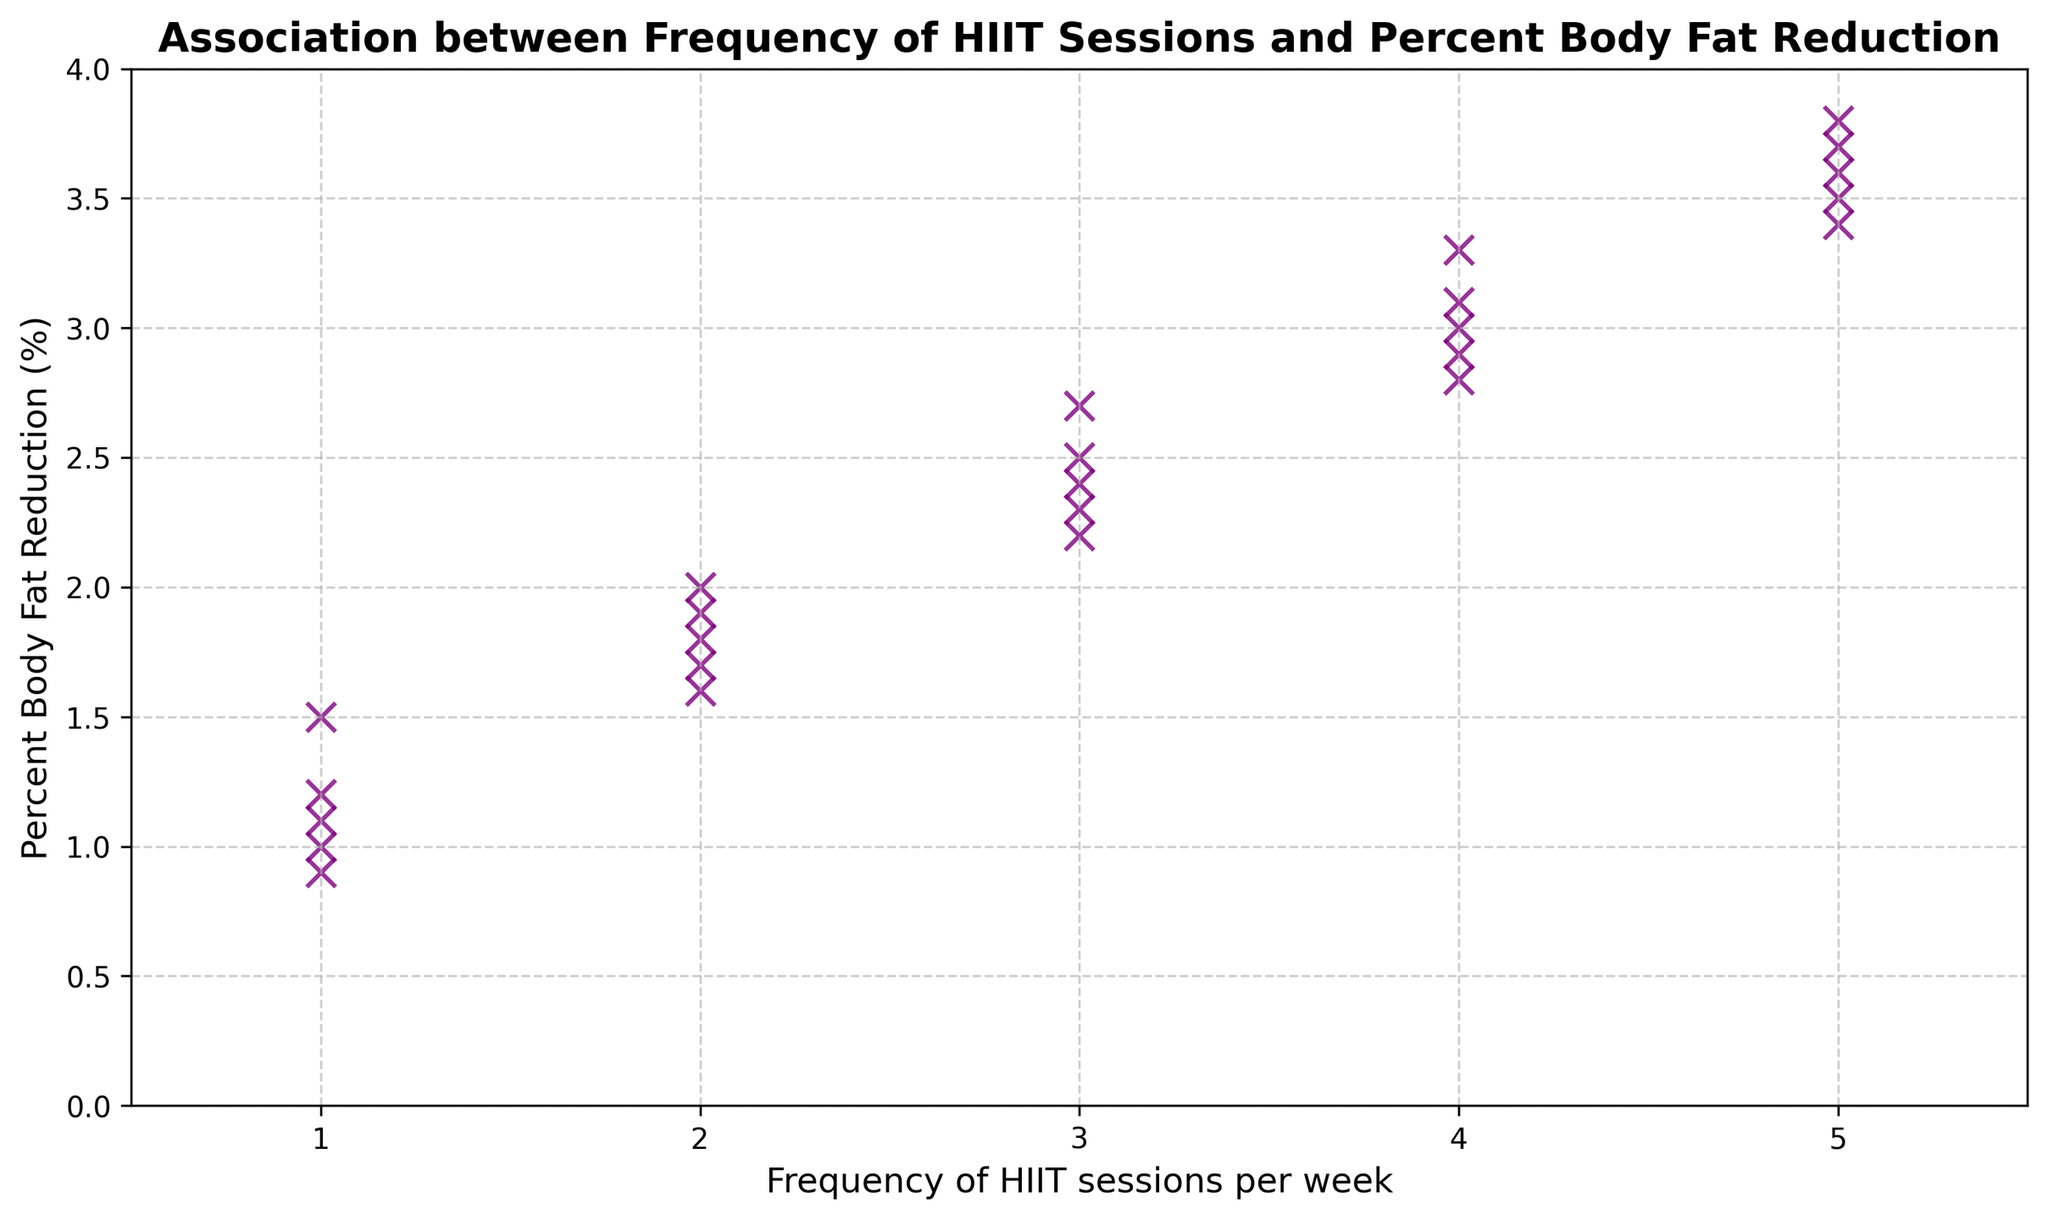What is the maximum percent body fat reduction observed for any frequency of HIIT sessions? To determine the maximum percent body fat reduction, look at the data points and find the one with the highest Y-value. The highest observed percent body fat reduction is for 5 sessions per week, which corresponds to 3.8%.
Answer: 3.8% What is the trend in percent body fat reduction as the frequency of HIIT sessions increases? Observing the scatter plot, one can see an increasing trend in percent body fat reduction as the frequency of HIIT sessions per week increases. The points generally move upward as the frequency increases from 1 to 5 sessions per week.
Answer: Increasing trend What is the average percent body fat reduction for 3 HIIT sessions per week? Locate the data points corresponding to 3 HIIT sessions per week, which are 2.5%, 2.7%, 2.3%, 2.4%, and 2.2%. Calculate the average of these values: (2.5 + 2.7 + 2.3 + 2.4 + 2.2) / 5 = 12.1 / 5 = 2.42%.
Answer: 2.42% For which frequency of HIIT sessions is the percent body fat reduction closest to 3%? Identify the data points that are closest to 3% on the Y-axis. The frequency for these points is 4 sessions per week with reductions of 3.0% and 3.1%.
Answer: 4 sessions per week How much more percent body fat reduction is achieved with 4 HIIT sessions compared to 2 HIIT sessions on average? First, find the average reduction for 4 sessions per week: (3.0 + 3.3 + 2.9 + 3.1 + 2.8) / 5 = 15.1 / 5 = 3.02%. Then, find the average for 2 sessions per week: (1.8 + 2.0 + 1.7 + 1.9 + 1.6) / 5 = 9.0 / 5 = 1.8%. Subtract the average for 2 sessions from that of 4 sessions: 3.02 - 1.8 = 1.22%.
Answer: 1.22% Which frequency of HIIT sessions shows the smallest variability in percent body fat reduction? To determine variability, observe the spread of data points on the Y-axis for each frequency. For 5 sessions per week, the reduction values are close to each other (3.6, 3.8, 3.5, 3.7, 3.4), indicating the smallest variability.
Answer: 5 sessions per week What is the overall pattern in the relationship between frequency of HIIT sessions and percent body fat reduction demonstrated in this plot? The pattern shows a positive correlation: as the frequency of HIIT sessions increases, the percent body fat reduction also tends to increase, indicated by the upward trend of the data points.
Answer: Positive correlation 